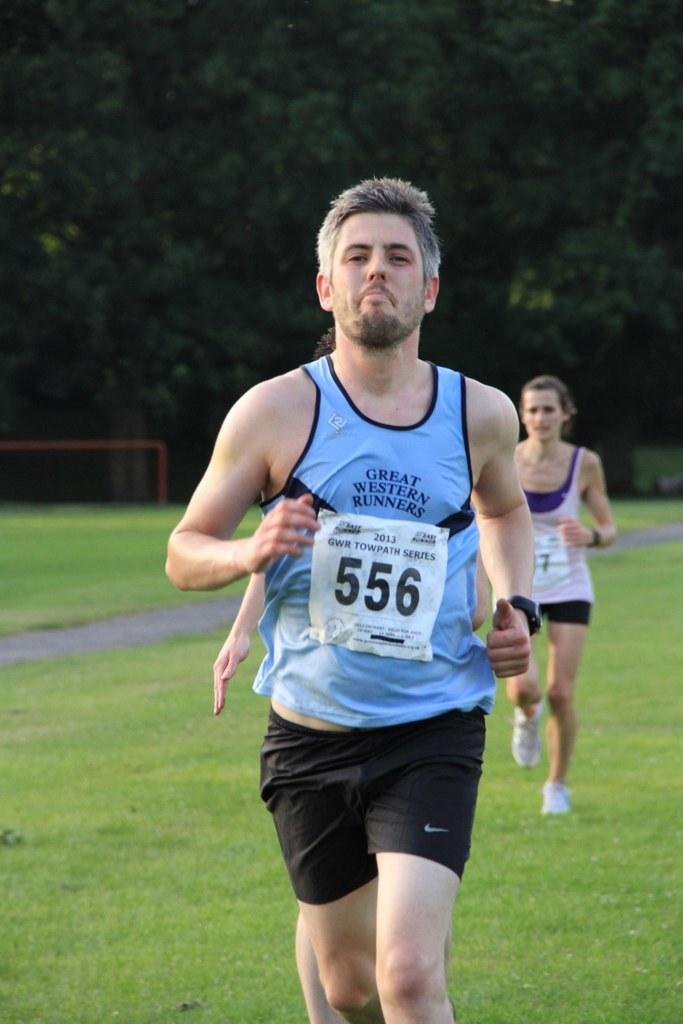What is the runner's designated number?
Offer a terse response. 556. 